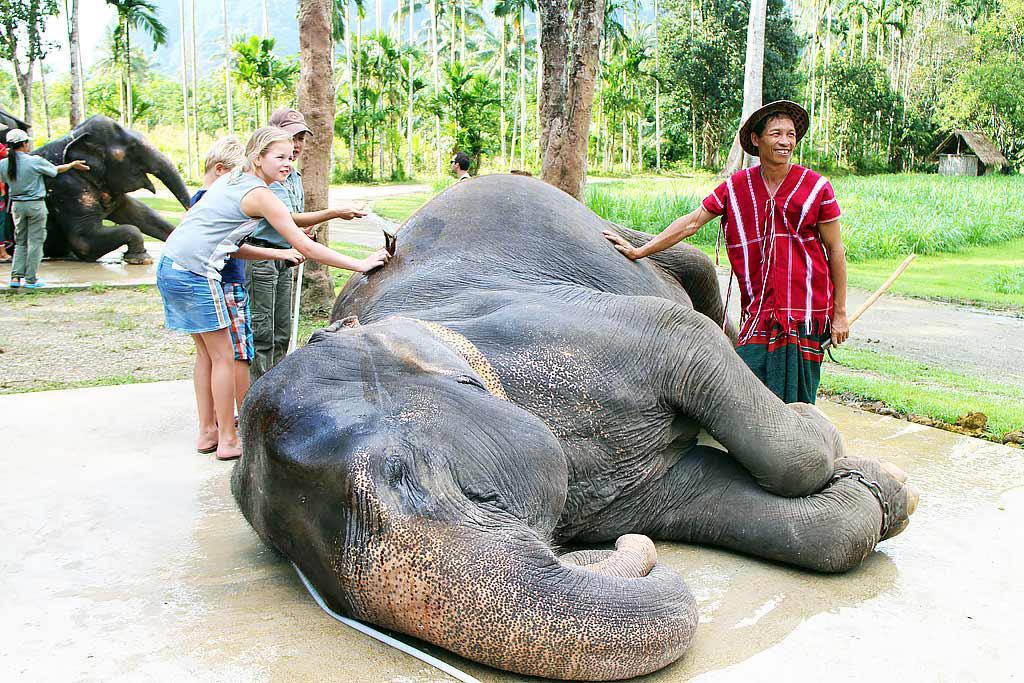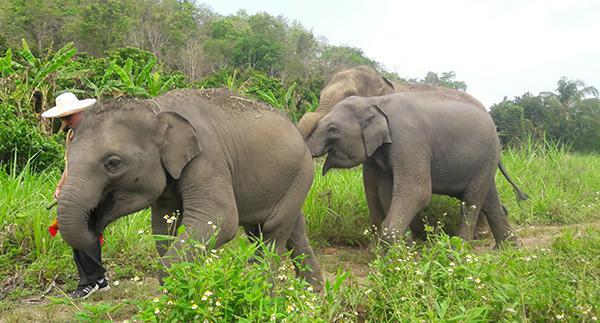The first image is the image on the left, the second image is the image on the right. Given the left and right images, does the statement "The elephant on the left is being attended to by humans." hold true? Answer yes or no. Yes. The first image is the image on the left, the second image is the image on the right. Considering the images on both sides, is "The left image shows humans interacting with an elephant." valid? Answer yes or no. Yes. 